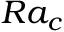Convert formula to latex. <formula><loc_0><loc_0><loc_500><loc_500>R a _ { c }</formula> 